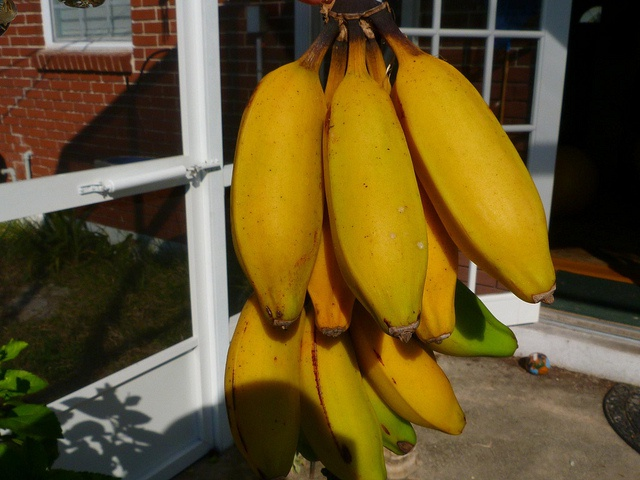Describe the objects in this image and their specific colors. I can see banana in black, olive, and orange tones and banana in black, olive, orange, and maroon tones in this image. 